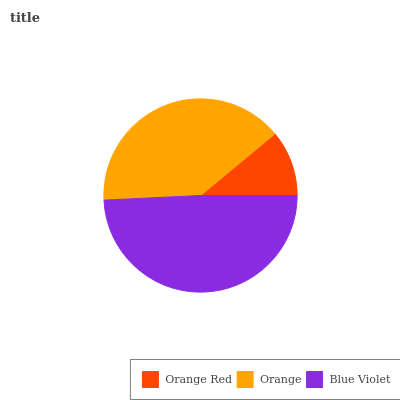Is Orange Red the minimum?
Answer yes or no. Yes. Is Blue Violet the maximum?
Answer yes or no. Yes. Is Orange the minimum?
Answer yes or no. No. Is Orange the maximum?
Answer yes or no. No. Is Orange greater than Orange Red?
Answer yes or no. Yes. Is Orange Red less than Orange?
Answer yes or no. Yes. Is Orange Red greater than Orange?
Answer yes or no. No. Is Orange less than Orange Red?
Answer yes or no. No. Is Orange the high median?
Answer yes or no. Yes. Is Orange the low median?
Answer yes or no. Yes. Is Orange Red the high median?
Answer yes or no. No. Is Orange Red the low median?
Answer yes or no. No. 